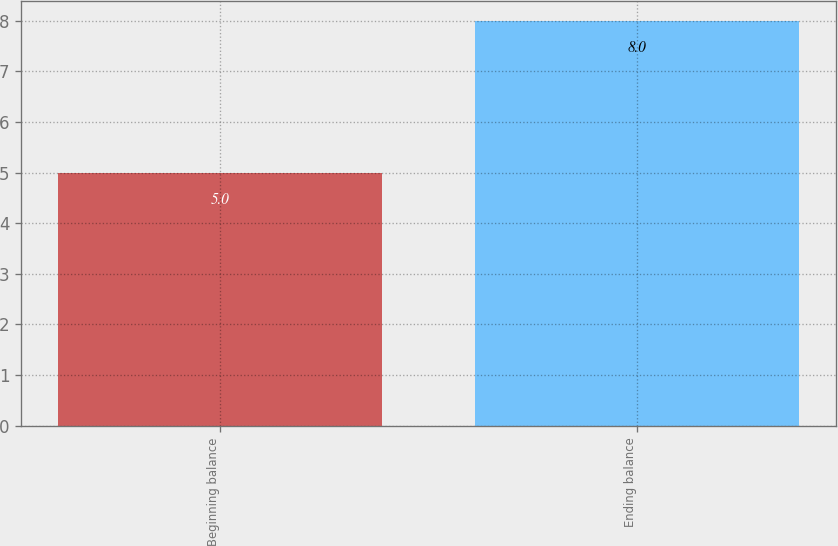<chart> <loc_0><loc_0><loc_500><loc_500><bar_chart><fcel>Beginning balance<fcel>Ending balance<nl><fcel>5<fcel>8<nl></chart> 